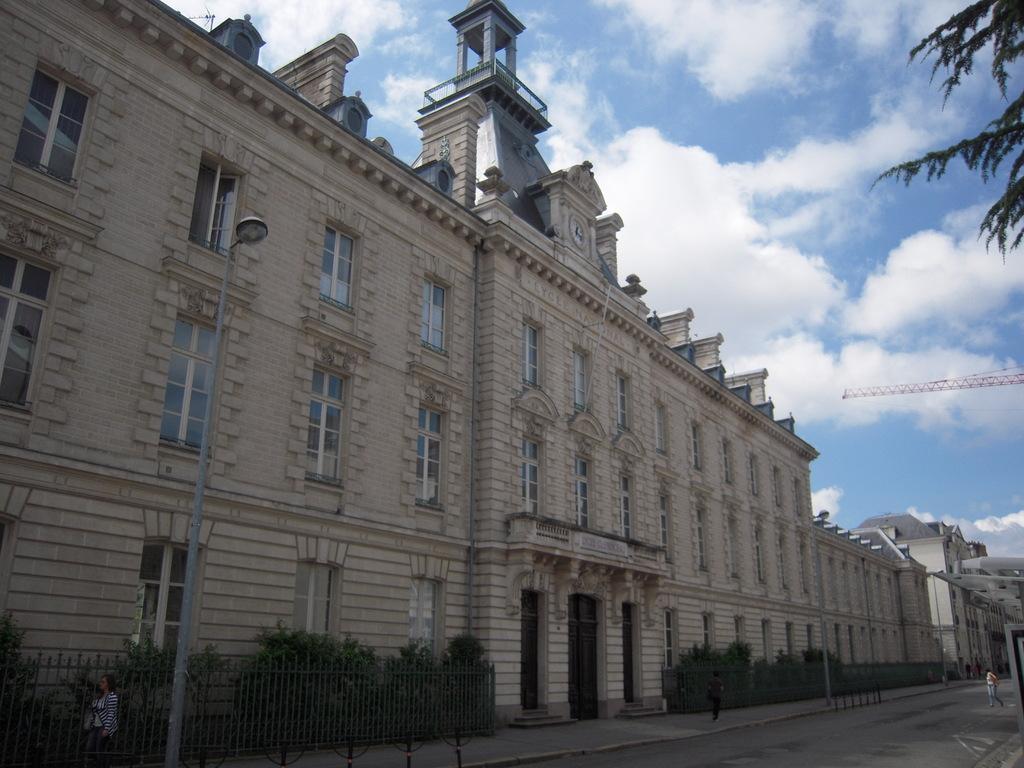Please provide a concise description of this image. In this image on the left, there are buildings, windows, plants, street lights, pillars, wall. On the right there are trees, person, road, sky and clouds. 